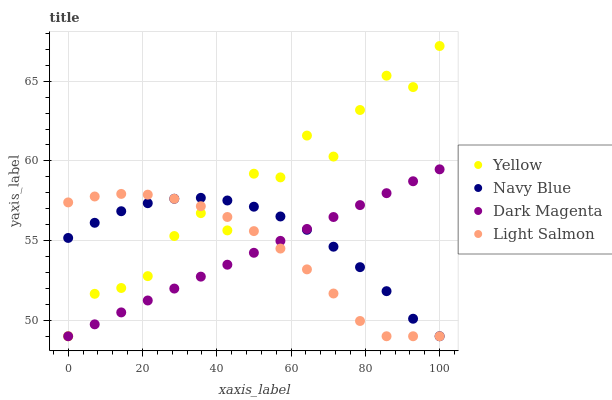Does Dark Magenta have the minimum area under the curve?
Answer yes or no. Yes. Does Yellow have the maximum area under the curve?
Answer yes or no. Yes. Does Light Salmon have the minimum area under the curve?
Answer yes or no. No. Does Light Salmon have the maximum area under the curve?
Answer yes or no. No. Is Dark Magenta the smoothest?
Answer yes or no. Yes. Is Yellow the roughest?
Answer yes or no. Yes. Is Light Salmon the smoothest?
Answer yes or no. No. Is Light Salmon the roughest?
Answer yes or no. No. Does Navy Blue have the lowest value?
Answer yes or no. Yes. Does Yellow have the highest value?
Answer yes or no. Yes. Does Light Salmon have the highest value?
Answer yes or no. No. Does Light Salmon intersect Navy Blue?
Answer yes or no. Yes. Is Light Salmon less than Navy Blue?
Answer yes or no. No. Is Light Salmon greater than Navy Blue?
Answer yes or no. No. 